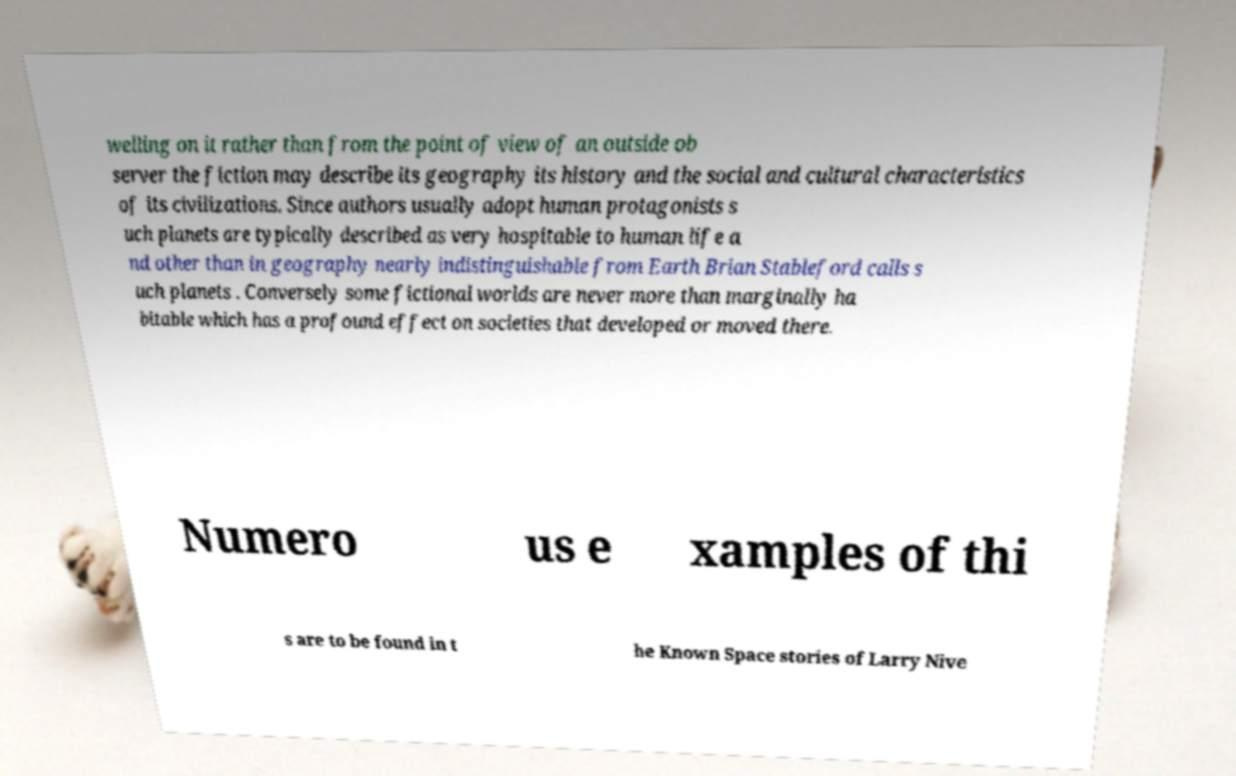What messages or text are displayed in this image? I need them in a readable, typed format. welling on it rather than from the point of view of an outside ob server the fiction may describe its geography its history and the social and cultural characteristics of its civilizations. Since authors usually adopt human protagonists s uch planets are typically described as very hospitable to human life a nd other than in geography nearly indistinguishable from Earth Brian Stableford calls s uch planets . Conversely some fictional worlds are never more than marginally ha bitable which has a profound effect on societies that developed or moved there. Numero us e xamples of thi s are to be found in t he Known Space stories of Larry Nive 